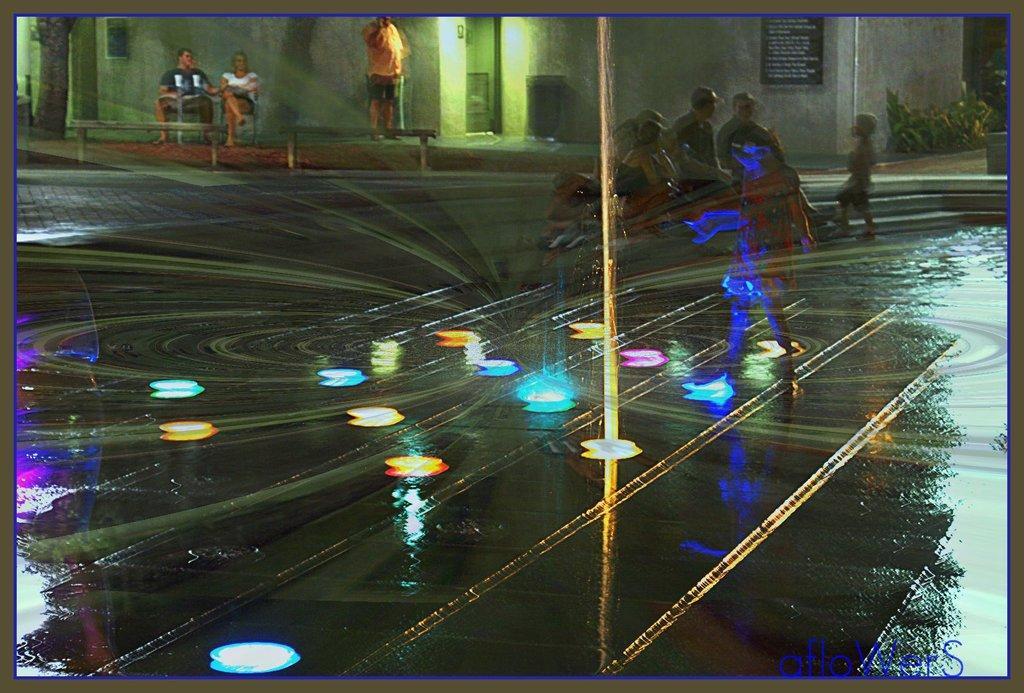Can you describe this image briefly? In this image there are some people some of them are sitting and some of them are standing, and at the bottom there are some water falls and some lights. And in the background there is a house, and some plants and trees. 